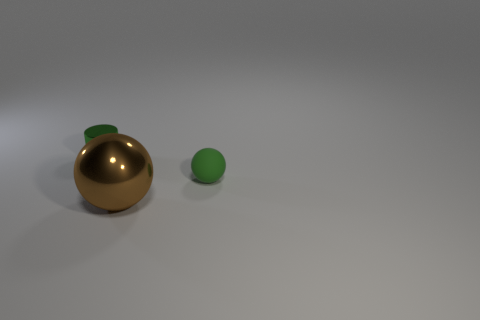Is the shape of the thing behind the small rubber ball the same as the green thing to the right of the brown object?
Your answer should be very brief. No. There is a green object that is the same size as the green ball; what shape is it?
Provide a short and direct response. Cylinder. How many metallic things are balls or tiny objects?
Give a very brief answer. 2. Is the small green object on the left side of the big brown thing made of the same material as the thing that is on the right side of the brown thing?
Provide a short and direct response. No. The cylinder that is made of the same material as the large object is what color?
Your answer should be compact. Green. Is the number of spheres that are to the left of the large metal ball greater than the number of things that are to the left of the tiny green matte thing?
Make the answer very short. No. Are there any big purple matte cylinders?
Your answer should be very brief. No. What is the material of the tiny ball that is the same color as the small metal thing?
Provide a short and direct response. Rubber. What number of objects are cyan metallic cubes or spheres?
Your response must be concise. 2. Is there a tiny metal object that has the same color as the matte object?
Make the answer very short. Yes. 